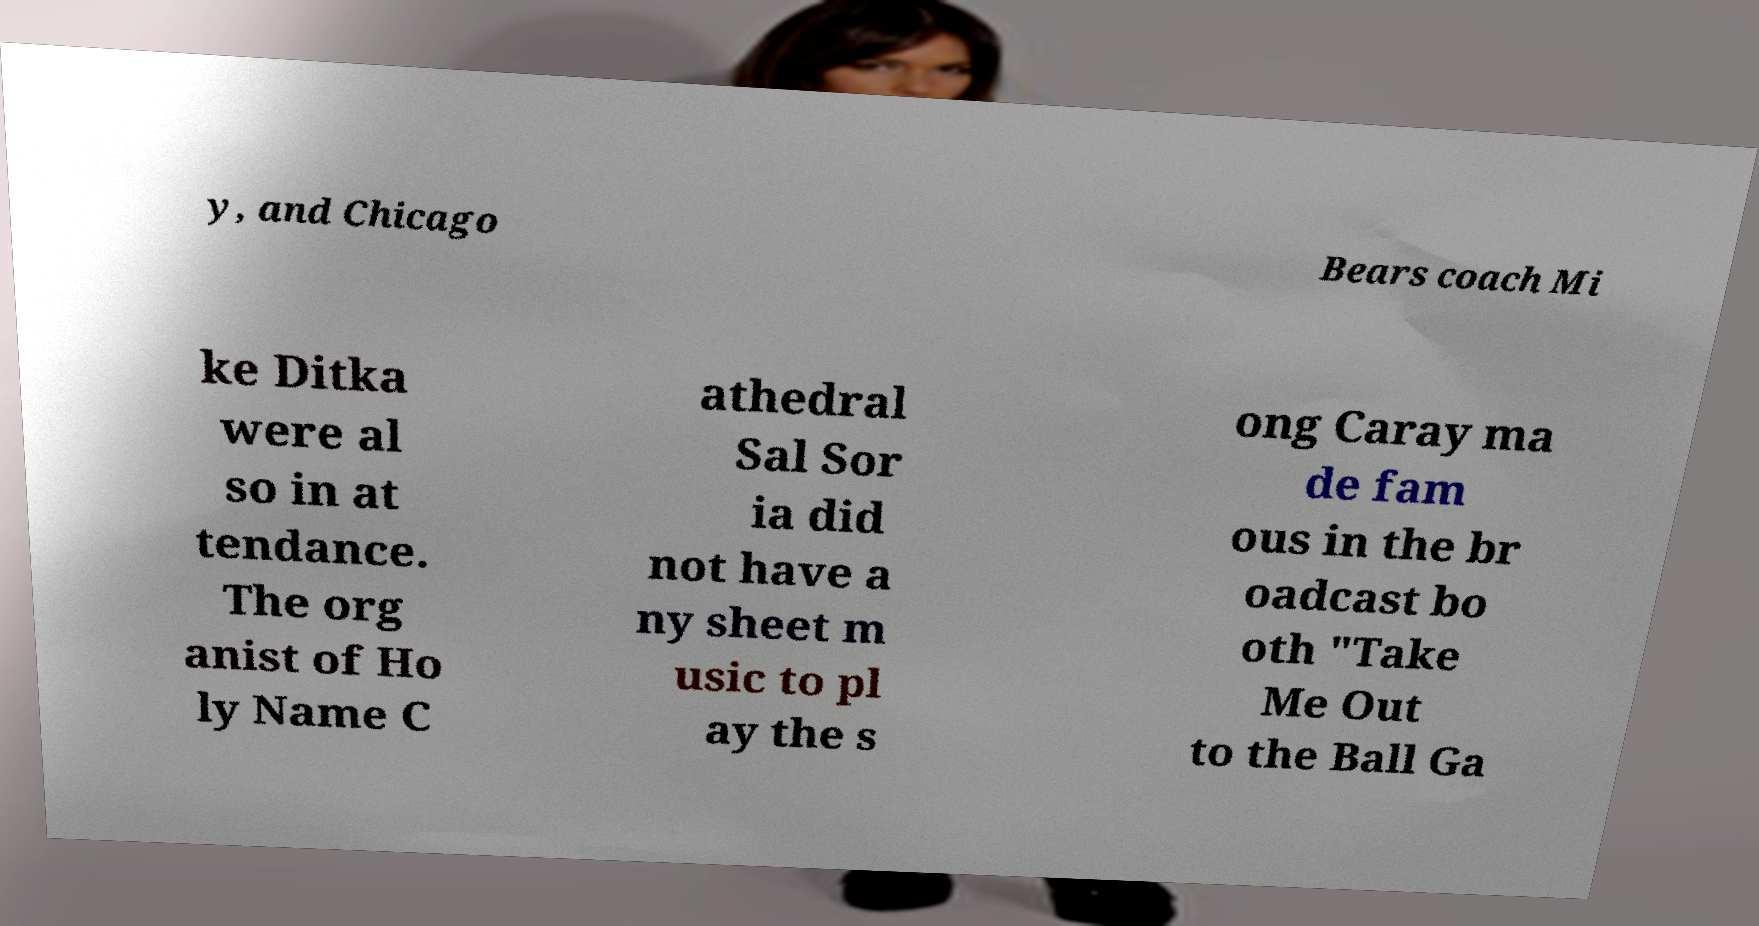Could you extract and type out the text from this image? y, and Chicago Bears coach Mi ke Ditka were al so in at tendance. The org anist of Ho ly Name C athedral Sal Sor ia did not have a ny sheet m usic to pl ay the s ong Caray ma de fam ous in the br oadcast bo oth "Take Me Out to the Ball Ga 